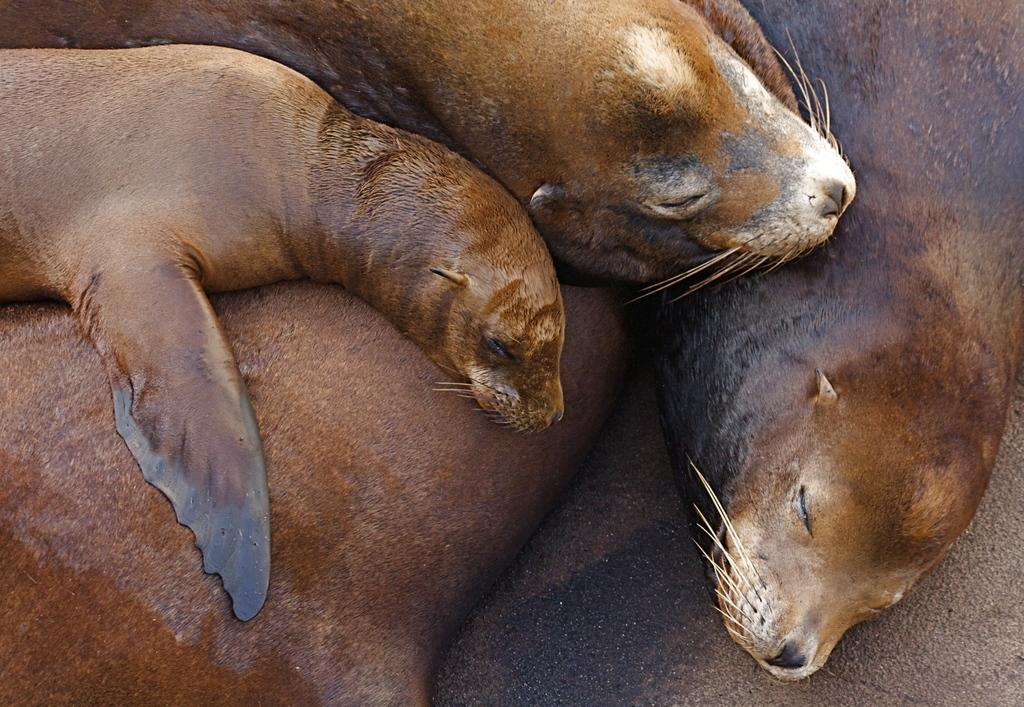What animals are present in the image? There are seals in the image. What are the seals doing in the image? The seals are lying down. What surface are the seals lying on? There is a floor visible in the image. What type of fang can be seen in the image? There are no fangs present in the image; it features seals lying down on a floor. What is the tendency of the seals to wear jeans in the image? There is no mention of jeans or any clothing in the image, and seals do not wear clothing. 